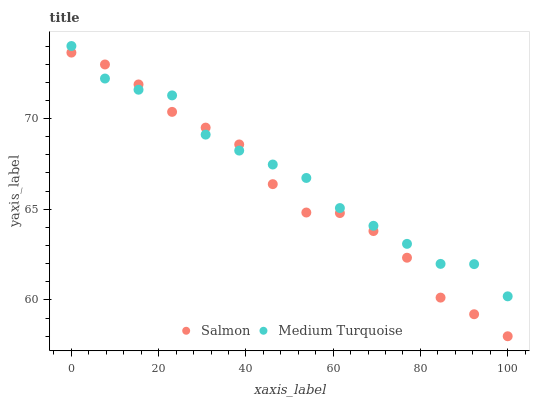Does Salmon have the minimum area under the curve?
Answer yes or no. Yes. Does Medium Turquoise have the maximum area under the curve?
Answer yes or no. Yes. Does Medium Turquoise have the minimum area under the curve?
Answer yes or no. No. Is Salmon the smoothest?
Answer yes or no. Yes. Is Medium Turquoise the roughest?
Answer yes or no. Yes. Is Medium Turquoise the smoothest?
Answer yes or no. No. Does Salmon have the lowest value?
Answer yes or no. Yes. Does Medium Turquoise have the lowest value?
Answer yes or no. No. Does Medium Turquoise have the highest value?
Answer yes or no. Yes. Does Medium Turquoise intersect Salmon?
Answer yes or no. Yes. Is Medium Turquoise less than Salmon?
Answer yes or no. No. Is Medium Turquoise greater than Salmon?
Answer yes or no. No. 